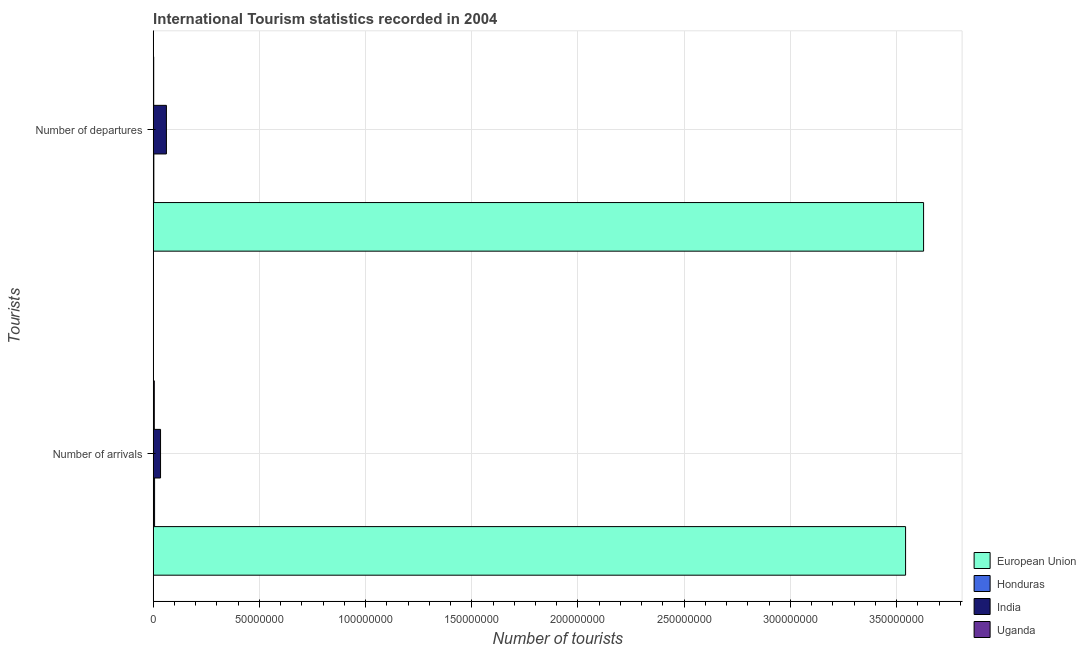Are the number of bars on each tick of the Y-axis equal?
Make the answer very short. Yes. How many bars are there on the 1st tick from the bottom?
Provide a succinct answer. 4. What is the label of the 1st group of bars from the top?
Give a very brief answer. Number of departures. What is the number of tourist arrivals in European Union?
Ensure brevity in your answer.  3.54e+08. Across all countries, what is the maximum number of tourist arrivals?
Your answer should be compact. 3.54e+08. Across all countries, what is the minimum number of tourist arrivals?
Your answer should be very brief. 5.12e+05. In which country was the number of tourist arrivals maximum?
Make the answer very short. European Union. In which country was the number of tourist departures minimum?
Your response must be concise. Uganda. What is the total number of tourist arrivals in the graph?
Keep it short and to the point. 3.59e+08. What is the difference between the number of tourist departures in India and that in European Union?
Your answer should be very brief. -3.57e+08. What is the difference between the number of tourist arrivals in Uganda and the number of tourist departures in India?
Give a very brief answer. -5.70e+06. What is the average number of tourist arrivals per country?
Ensure brevity in your answer.  8.97e+07. What is the difference between the number of tourist departures and number of tourist arrivals in European Union?
Your response must be concise. 8.48e+06. What is the ratio of the number of tourist departures in Honduras to that in Uganda?
Keep it short and to the point. 1.28. In how many countries, is the number of tourist arrivals greater than the average number of tourist arrivals taken over all countries?
Your answer should be compact. 1. How many countries are there in the graph?
Your response must be concise. 4. Does the graph contain any zero values?
Make the answer very short. No. Does the graph contain grids?
Keep it short and to the point. Yes. Where does the legend appear in the graph?
Provide a short and direct response. Bottom right. What is the title of the graph?
Ensure brevity in your answer.  International Tourism statistics recorded in 2004. What is the label or title of the X-axis?
Ensure brevity in your answer.  Number of tourists. What is the label or title of the Y-axis?
Give a very brief answer. Tourists. What is the Number of tourists of European Union in Number of arrivals?
Your answer should be very brief. 3.54e+08. What is the Number of tourists of Honduras in Number of arrivals?
Your answer should be very brief. 6.41e+05. What is the Number of tourists in India in Number of arrivals?
Ensure brevity in your answer.  3.46e+06. What is the Number of tourists of Uganda in Number of arrivals?
Provide a short and direct response. 5.12e+05. What is the Number of tourists of European Union in Number of departures?
Give a very brief answer. 3.63e+08. What is the Number of tourists in Honduras in Number of departures?
Your answer should be compact. 2.95e+05. What is the Number of tourists of India in Number of departures?
Offer a terse response. 6.21e+06. What is the Number of tourists of Uganda in Number of departures?
Ensure brevity in your answer.  2.31e+05. Across all Tourists, what is the maximum Number of tourists in European Union?
Provide a short and direct response. 3.63e+08. Across all Tourists, what is the maximum Number of tourists of Honduras?
Your response must be concise. 6.41e+05. Across all Tourists, what is the maximum Number of tourists of India?
Keep it short and to the point. 6.21e+06. Across all Tourists, what is the maximum Number of tourists of Uganda?
Provide a succinct answer. 5.12e+05. Across all Tourists, what is the minimum Number of tourists in European Union?
Keep it short and to the point. 3.54e+08. Across all Tourists, what is the minimum Number of tourists of Honduras?
Provide a succinct answer. 2.95e+05. Across all Tourists, what is the minimum Number of tourists of India?
Your answer should be very brief. 3.46e+06. Across all Tourists, what is the minimum Number of tourists of Uganda?
Offer a terse response. 2.31e+05. What is the total Number of tourists of European Union in the graph?
Keep it short and to the point. 7.17e+08. What is the total Number of tourists in Honduras in the graph?
Provide a succinct answer. 9.36e+05. What is the total Number of tourists of India in the graph?
Make the answer very short. 9.67e+06. What is the total Number of tourists in Uganda in the graph?
Your response must be concise. 7.43e+05. What is the difference between the Number of tourists of European Union in Number of arrivals and that in Number of departures?
Your answer should be very brief. -8.48e+06. What is the difference between the Number of tourists of Honduras in Number of arrivals and that in Number of departures?
Provide a succinct answer. 3.46e+05. What is the difference between the Number of tourists of India in Number of arrivals and that in Number of departures?
Ensure brevity in your answer.  -2.76e+06. What is the difference between the Number of tourists of Uganda in Number of arrivals and that in Number of departures?
Your answer should be very brief. 2.81e+05. What is the difference between the Number of tourists of European Union in Number of arrivals and the Number of tourists of Honduras in Number of departures?
Provide a succinct answer. 3.54e+08. What is the difference between the Number of tourists of European Union in Number of arrivals and the Number of tourists of India in Number of departures?
Offer a terse response. 3.48e+08. What is the difference between the Number of tourists of European Union in Number of arrivals and the Number of tourists of Uganda in Number of departures?
Ensure brevity in your answer.  3.54e+08. What is the difference between the Number of tourists of Honduras in Number of arrivals and the Number of tourists of India in Number of departures?
Give a very brief answer. -5.57e+06. What is the difference between the Number of tourists of Honduras in Number of arrivals and the Number of tourists of Uganda in Number of departures?
Offer a very short reply. 4.10e+05. What is the difference between the Number of tourists of India in Number of arrivals and the Number of tourists of Uganda in Number of departures?
Your answer should be compact. 3.23e+06. What is the average Number of tourists of European Union per Tourists?
Ensure brevity in your answer.  3.58e+08. What is the average Number of tourists in Honduras per Tourists?
Give a very brief answer. 4.68e+05. What is the average Number of tourists of India per Tourists?
Offer a terse response. 4.84e+06. What is the average Number of tourists in Uganda per Tourists?
Your answer should be compact. 3.72e+05. What is the difference between the Number of tourists of European Union and Number of tourists of Honduras in Number of arrivals?
Your answer should be very brief. 3.54e+08. What is the difference between the Number of tourists of European Union and Number of tourists of India in Number of arrivals?
Offer a terse response. 3.51e+08. What is the difference between the Number of tourists in European Union and Number of tourists in Uganda in Number of arrivals?
Ensure brevity in your answer.  3.54e+08. What is the difference between the Number of tourists of Honduras and Number of tourists of India in Number of arrivals?
Your answer should be very brief. -2.82e+06. What is the difference between the Number of tourists in Honduras and Number of tourists in Uganda in Number of arrivals?
Your response must be concise. 1.29e+05. What is the difference between the Number of tourists of India and Number of tourists of Uganda in Number of arrivals?
Ensure brevity in your answer.  2.94e+06. What is the difference between the Number of tourists in European Union and Number of tourists in Honduras in Number of departures?
Offer a very short reply. 3.62e+08. What is the difference between the Number of tourists in European Union and Number of tourists in India in Number of departures?
Your answer should be very brief. 3.57e+08. What is the difference between the Number of tourists in European Union and Number of tourists in Uganda in Number of departures?
Your answer should be compact. 3.63e+08. What is the difference between the Number of tourists in Honduras and Number of tourists in India in Number of departures?
Ensure brevity in your answer.  -5.92e+06. What is the difference between the Number of tourists in Honduras and Number of tourists in Uganda in Number of departures?
Ensure brevity in your answer.  6.40e+04. What is the difference between the Number of tourists of India and Number of tourists of Uganda in Number of departures?
Provide a short and direct response. 5.98e+06. What is the ratio of the Number of tourists in European Union in Number of arrivals to that in Number of departures?
Give a very brief answer. 0.98. What is the ratio of the Number of tourists of Honduras in Number of arrivals to that in Number of departures?
Make the answer very short. 2.17. What is the ratio of the Number of tourists of India in Number of arrivals to that in Number of departures?
Provide a succinct answer. 0.56. What is the ratio of the Number of tourists of Uganda in Number of arrivals to that in Number of departures?
Make the answer very short. 2.22. What is the difference between the highest and the second highest Number of tourists of European Union?
Your response must be concise. 8.48e+06. What is the difference between the highest and the second highest Number of tourists of Honduras?
Your answer should be compact. 3.46e+05. What is the difference between the highest and the second highest Number of tourists in India?
Provide a short and direct response. 2.76e+06. What is the difference between the highest and the second highest Number of tourists in Uganda?
Provide a succinct answer. 2.81e+05. What is the difference between the highest and the lowest Number of tourists of European Union?
Keep it short and to the point. 8.48e+06. What is the difference between the highest and the lowest Number of tourists in Honduras?
Your response must be concise. 3.46e+05. What is the difference between the highest and the lowest Number of tourists of India?
Ensure brevity in your answer.  2.76e+06. What is the difference between the highest and the lowest Number of tourists in Uganda?
Your response must be concise. 2.81e+05. 